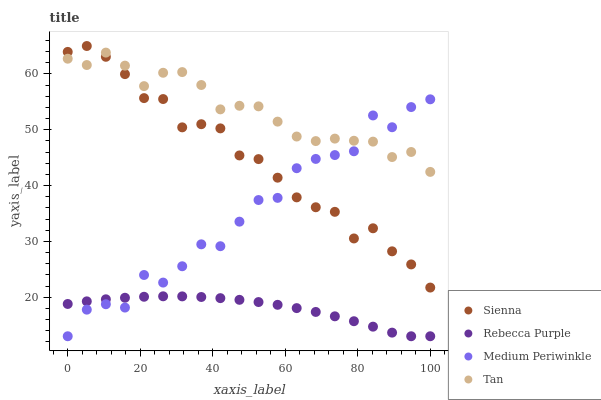Does Rebecca Purple have the minimum area under the curve?
Answer yes or no. Yes. Does Tan have the maximum area under the curve?
Answer yes or no. Yes. Does Medium Periwinkle have the minimum area under the curve?
Answer yes or no. No. Does Medium Periwinkle have the maximum area under the curve?
Answer yes or no. No. Is Rebecca Purple the smoothest?
Answer yes or no. Yes. Is Medium Periwinkle the roughest?
Answer yes or no. Yes. Is Tan the smoothest?
Answer yes or no. No. Is Tan the roughest?
Answer yes or no. No. Does Medium Periwinkle have the lowest value?
Answer yes or no. Yes. Does Tan have the lowest value?
Answer yes or no. No. Does Sienna have the highest value?
Answer yes or no. Yes. Does Tan have the highest value?
Answer yes or no. No. Is Rebecca Purple less than Sienna?
Answer yes or no. Yes. Is Tan greater than Rebecca Purple?
Answer yes or no. Yes. Does Tan intersect Sienna?
Answer yes or no. Yes. Is Tan less than Sienna?
Answer yes or no. No. Is Tan greater than Sienna?
Answer yes or no. No. Does Rebecca Purple intersect Sienna?
Answer yes or no. No. 